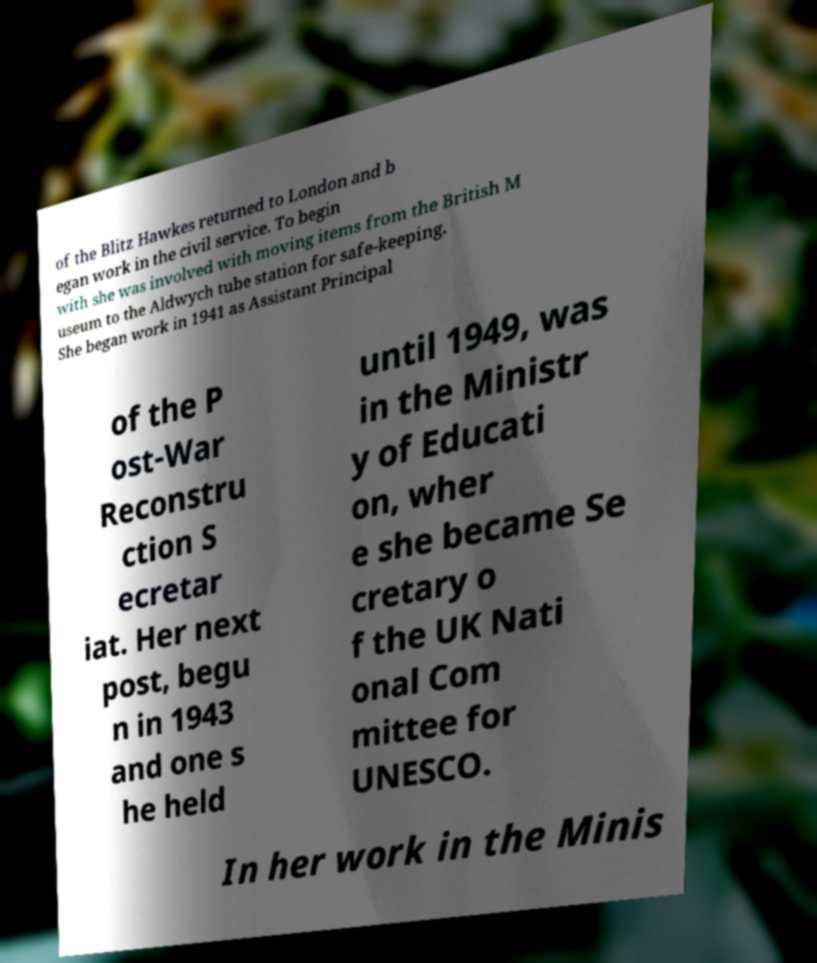Please identify and transcribe the text found in this image. of the Blitz Hawkes returned to London and b egan work in the civil service. To begin with she was involved with moving items from the British M useum to the Aldwych tube station for safe-keeping. She began work in 1941 as Assistant Principal of the P ost-War Reconstru ction S ecretar iat. Her next post, begu n in 1943 and one s he held until 1949, was in the Ministr y of Educati on, wher e she became Se cretary o f the UK Nati onal Com mittee for UNESCO. In her work in the Minis 